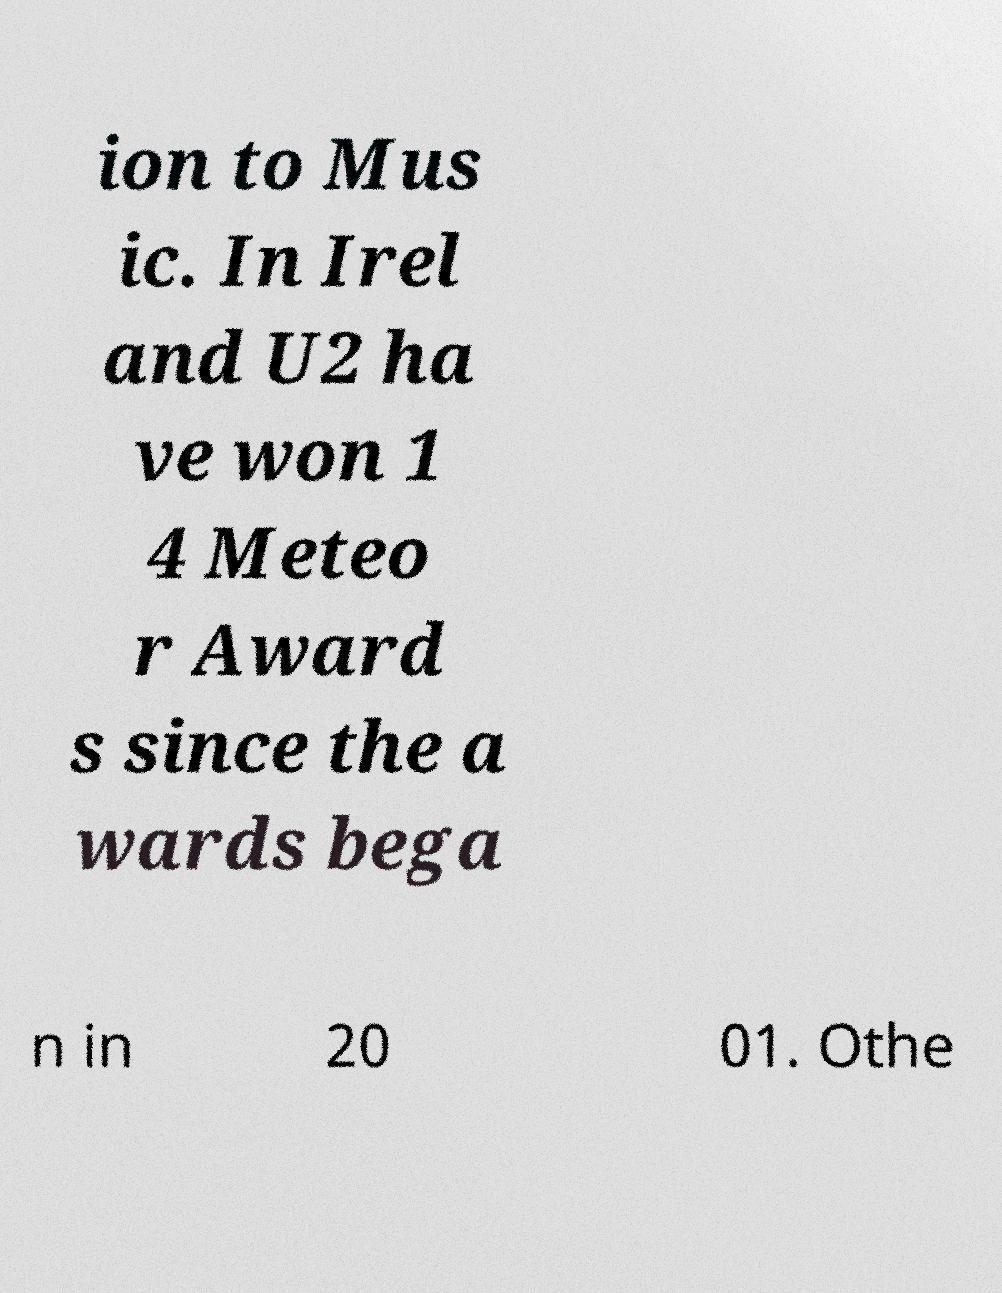For documentation purposes, I need the text within this image transcribed. Could you provide that? ion to Mus ic. In Irel and U2 ha ve won 1 4 Meteo r Award s since the a wards bega n in 20 01. Othe 